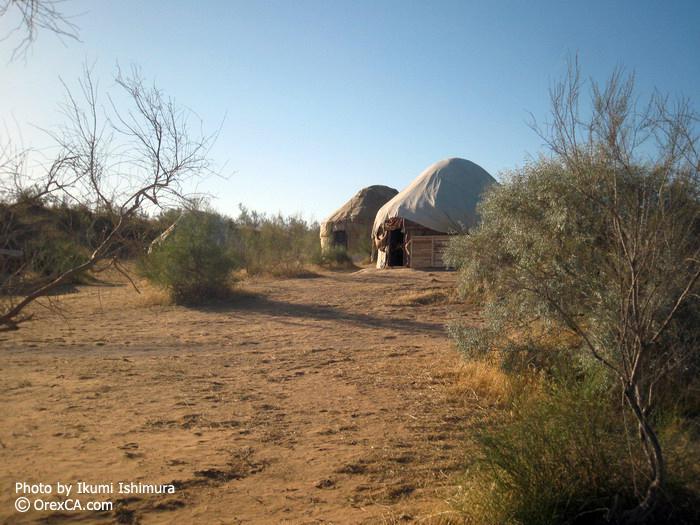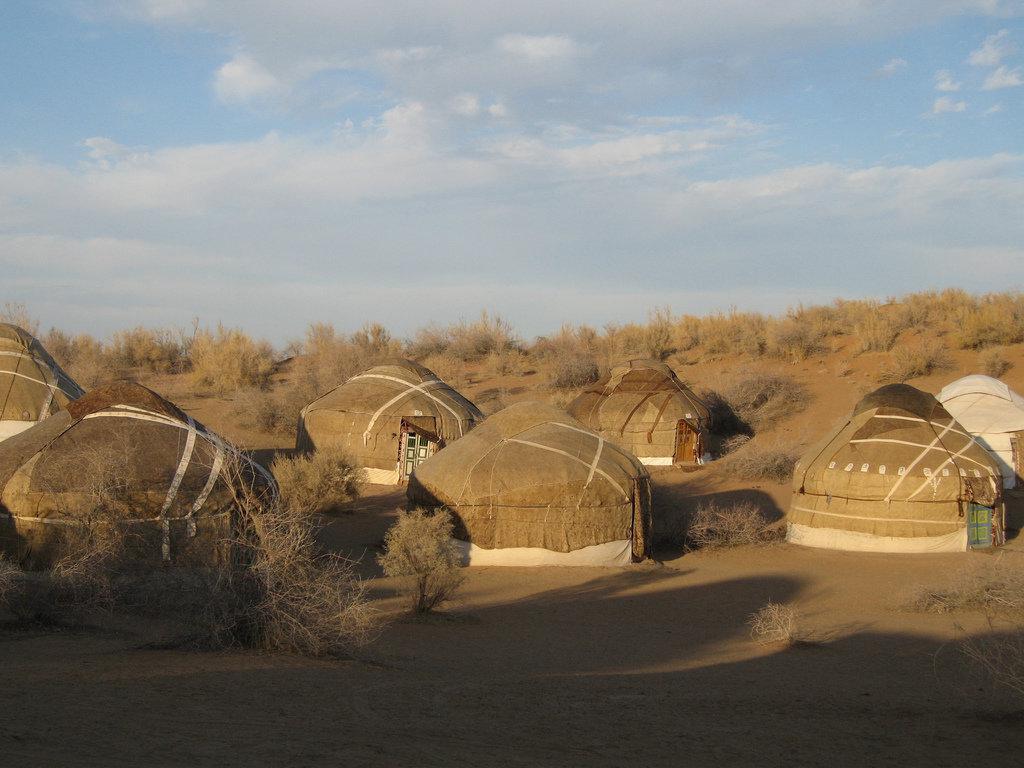The first image is the image on the left, the second image is the image on the right. For the images shown, is this caption "An image shows a group of round structures covered in brown material crossed with straps." true? Answer yes or no. Yes. The first image is the image on the left, the second image is the image on the right. For the images displayed, is the sentence "At least seven yurts of the same style are shown in a scrubby dessert setting in one image, while a second image shows at least 2 yurts." factually correct? Answer yes or no. Yes. 